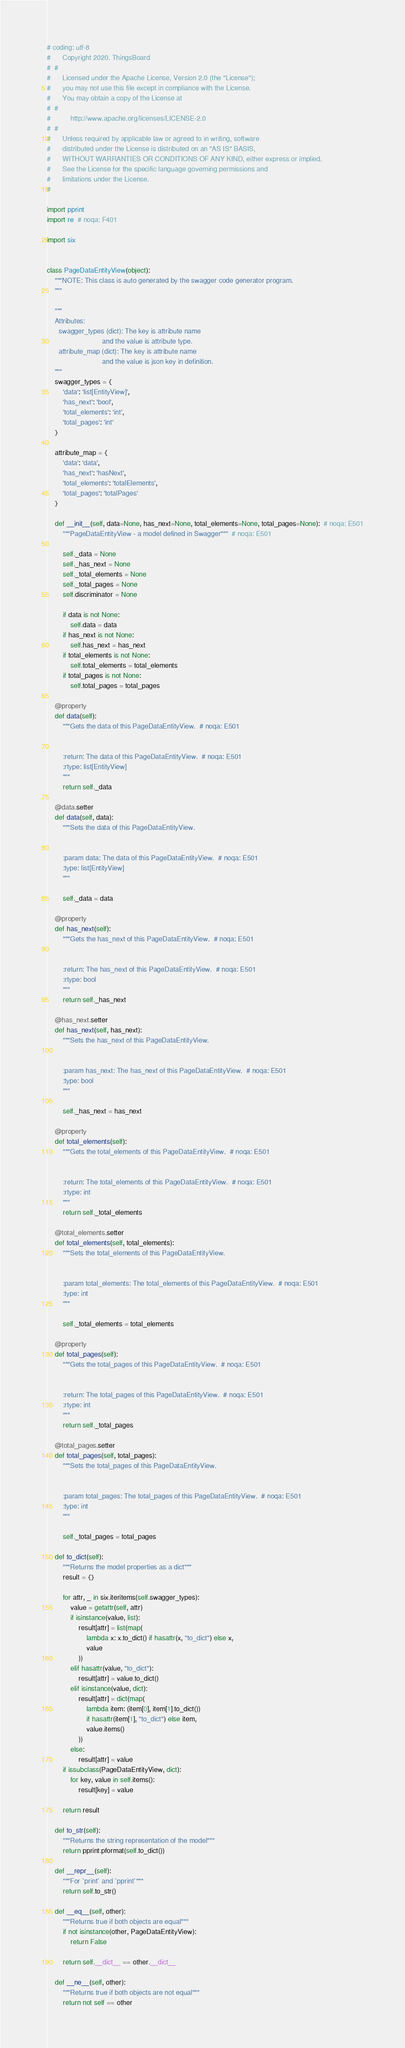Convert code to text. <code><loc_0><loc_0><loc_500><loc_500><_Python_># coding: utf-8
#      Copyright 2020. ThingsBoard
#  #
#      Licensed under the Apache License, Version 2.0 (the "License");
#      you may not use this file except in compliance with the License.
#      You may obtain a copy of the License at
#  #
#          http://www.apache.org/licenses/LICENSE-2.0
#  #
#      Unless required by applicable law or agreed to in writing, software
#      distributed under the License is distributed on an "AS IS" BASIS,
#      WITHOUT WARRANTIES OR CONDITIONS OF ANY KIND, either express or implied.
#      See the License for the specific language governing permissions and
#      limitations under the License.
#

import pprint
import re  # noqa: F401

import six


class PageDataEntityView(object):
    """NOTE: This class is auto generated by the swagger code generator program.
    """

    """
    Attributes:
      swagger_types (dict): The key is attribute name
                            and the value is attribute type.
      attribute_map (dict): The key is attribute name
                            and the value is json key in definition.
    """
    swagger_types = {
        'data': 'list[EntityView]',
        'has_next': 'bool',
        'total_elements': 'int',
        'total_pages': 'int'
    }

    attribute_map = {
        'data': 'data',
        'has_next': 'hasNext',
        'total_elements': 'totalElements',
        'total_pages': 'totalPages'
    }

    def __init__(self, data=None, has_next=None, total_elements=None, total_pages=None):  # noqa: E501
        """PageDataEntityView - a model defined in Swagger"""  # noqa: E501

        self._data = None
        self._has_next = None
        self._total_elements = None
        self._total_pages = None
        self.discriminator = None

        if data is not None:
            self.data = data
        if has_next is not None:
            self.has_next = has_next
        if total_elements is not None:
            self.total_elements = total_elements
        if total_pages is not None:
            self.total_pages = total_pages

    @property
    def data(self):
        """Gets the data of this PageDataEntityView.  # noqa: E501


        :return: The data of this PageDataEntityView.  # noqa: E501
        :rtype: list[EntityView]
        """
        return self._data

    @data.setter
    def data(self, data):
        """Sets the data of this PageDataEntityView.


        :param data: The data of this PageDataEntityView.  # noqa: E501
        :type: list[EntityView]
        """

        self._data = data

    @property
    def has_next(self):
        """Gets the has_next of this PageDataEntityView.  # noqa: E501


        :return: The has_next of this PageDataEntityView.  # noqa: E501
        :rtype: bool
        """
        return self._has_next

    @has_next.setter
    def has_next(self, has_next):
        """Sets the has_next of this PageDataEntityView.


        :param has_next: The has_next of this PageDataEntityView.  # noqa: E501
        :type: bool
        """

        self._has_next = has_next

    @property
    def total_elements(self):
        """Gets the total_elements of this PageDataEntityView.  # noqa: E501


        :return: The total_elements of this PageDataEntityView.  # noqa: E501
        :rtype: int
        """
        return self._total_elements

    @total_elements.setter
    def total_elements(self, total_elements):
        """Sets the total_elements of this PageDataEntityView.


        :param total_elements: The total_elements of this PageDataEntityView.  # noqa: E501
        :type: int
        """

        self._total_elements = total_elements

    @property
    def total_pages(self):
        """Gets the total_pages of this PageDataEntityView.  # noqa: E501


        :return: The total_pages of this PageDataEntityView.  # noqa: E501
        :rtype: int
        """
        return self._total_pages

    @total_pages.setter
    def total_pages(self, total_pages):
        """Sets the total_pages of this PageDataEntityView.


        :param total_pages: The total_pages of this PageDataEntityView.  # noqa: E501
        :type: int
        """

        self._total_pages = total_pages

    def to_dict(self):
        """Returns the model properties as a dict"""
        result = {}

        for attr, _ in six.iteritems(self.swagger_types):
            value = getattr(self, attr)
            if isinstance(value, list):
                result[attr] = list(map(
                    lambda x: x.to_dict() if hasattr(x, "to_dict") else x,
                    value
                ))
            elif hasattr(value, "to_dict"):
                result[attr] = value.to_dict()
            elif isinstance(value, dict):
                result[attr] = dict(map(
                    lambda item: (item[0], item[1].to_dict())
                    if hasattr(item[1], "to_dict") else item,
                    value.items()
                ))
            else:
                result[attr] = value
        if issubclass(PageDataEntityView, dict):
            for key, value in self.items():
                result[key] = value

        return result

    def to_str(self):
        """Returns the string representation of the model"""
        return pprint.pformat(self.to_dict())

    def __repr__(self):
        """For `print` and `pprint`"""
        return self.to_str()

    def __eq__(self, other):
        """Returns true if both objects are equal"""
        if not isinstance(other, PageDataEntityView):
            return False

        return self.__dict__ == other.__dict__

    def __ne__(self, other):
        """Returns true if both objects are not equal"""
        return not self == other
</code> 